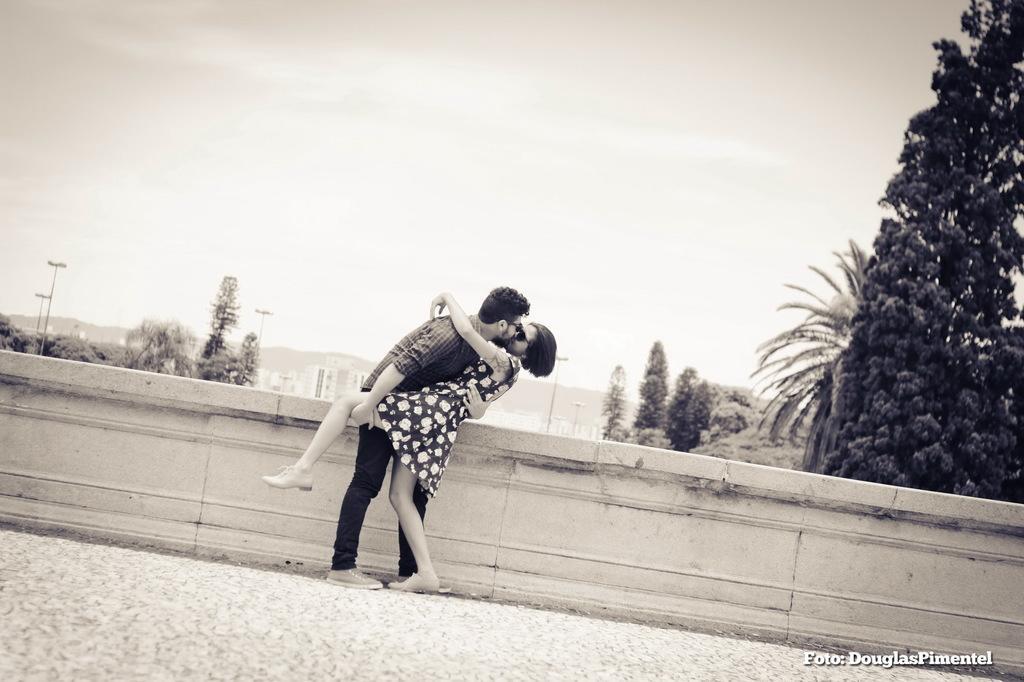Please provide a concise description of this image. In this image I can see a man and a woman are kissing each other. In the background I can see few trees, few poles, few buildings and the sky. 